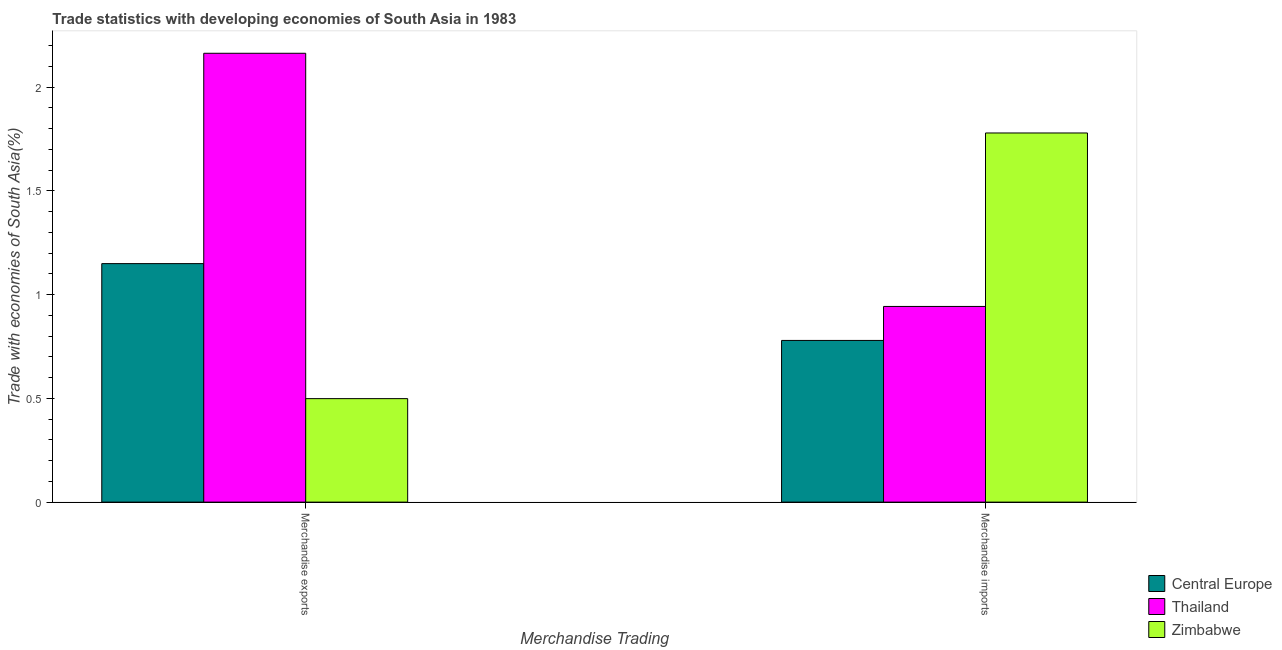Are the number of bars per tick equal to the number of legend labels?
Ensure brevity in your answer.  Yes. Are the number of bars on each tick of the X-axis equal?
Make the answer very short. Yes. How many bars are there on the 1st tick from the left?
Your answer should be very brief. 3. How many bars are there on the 1st tick from the right?
Ensure brevity in your answer.  3. What is the label of the 2nd group of bars from the left?
Ensure brevity in your answer.  Merchandise imports. What is the merchandise exports in Zimbabwe?
Make the answer very short. 0.5. Across all countries, what is the maximum merchandise imports?
Give a very brief answer. 1.78. Across all countries, what is the minimum merchandise imports?
Offer a very short reply. 0.78. In which country was the merchandise exports maximum?
Offer a very short reply. Thailand. In which country was the merchandise exports minimum?
Ensure brevity in your answer.  Zimbabwe. What is the total merchandise exports in the graph?
Your answer should be compact. 3.81. What is the difference between the merchandise imports in Zimbabwe and that in Central Europe?
Your answer should be very brief. 1. What is the difference between the merchandise imports in Zimbabwe and the merchandise exports in Central Europe?
Provide a short and direct response. 0.63. What is the average merchandise imports per country?
Provide a succinct answer. 1.17. What is the difference between the merchandise exports and merchandise imports in Central Europe?
Your answer should be very brief. 0.37. What is the ratio of the merchandise exports in Central Europe to that in Zimbabwe?
Ensure brevity in your answer.  2.3. What does the 3rd bar from the left in Merchandise imports represents?
Offer a terse response. Zimbabwe. What does the 1st bar from the right in Merchandise imports represents?
Offer a very short reply. Zimbabwe. How many bars are there?
Provide a succinct answer. 6. Are all the bars in the graph horizontal?
Make the answer very short. No. How many countries are there in the graph?
Provide a short and direct response. 3. Where does the legend appear in the graph?
Keep it short and to the point. Bottom right. How many legend labels are there?
Offer a very short reply. 3. How are the legend labels stacked?
Provide a succinct answer. Vertical. What is the title of the graph?
Provide a short and direct response. Trade statistics with developing economies of South Asia in 1983. What is the label or title of the X-axis?
Offer a very short reply. Merchandise Trading. What is the label or title of the Y-axis?
Make the answer very short. Trade with economies of South Asia(%). What is the Trade with economies of South Asia(%) in Central Europe in Merchandise exports?
Ensure brevity in your answer.  1.15. What is the Trade with economies of South Asia(%) in Thailand in Merchandise exports?
Give a very brief answer. 2.16. What is the Trade with economies of South Asia(%) of Zimbabwe in Merchandise exports?
Keep it short and to the point. 0.5. What is the Trade with economies of South Asia(%) of Central Europe in Merchandise imports?
Make the answer very short. 0.78. What is the Trade with economies of South Asia(%) in Thailand in Merchandise imports?
Your response must be concise. 0.94. What is the Trade with economies of South Asia(%) of Zimbabwe in Merchandise imports?
Your answer should be very brief. 1.78. Across all Merchandise Trading, what is the maximum Trade with economies of South Asia(%) in Central Europe?
Ensure brevity in your answer.  1.15. Across all Merchandise Trading, what is the maximum Trade with economies of South Asia(%) in Thailand?
Ensure brevity in your answer.  2.16. Across all Merchandise Trading, what is the maximum Trade with economies of South Asia(%) of Zimbabwe?
Your answer should be very brief. 1.78. Across all Merchandise Trading, what is the minimum Trade with economies of South Asia(%) of Central Europe?
Your response must be concise. 0.78. Across all Merchandise Trading, what is the minimum Trade with economies of South Asia(%) in Thailand?
Provide a short and direct response. 0.94. Across all Merchandise Trading, what is the minimum Trade with economies of South Asia(%) of Zimbabwe?
Your response must be concise. 0.5. What is the total Trade with economies of South Asia(%) in Central Europe in the graph?
Offer a terse response. 1.93. What is the total Trade with economies of South Asia(%) of Thailand in the graph?
Ensure brevity in your answer.  3.11. What is the total Trade with economies of South Asia(%) in Zimbabwe in the graph?
Your answer should be very brief. 2.28. What is the difference between the Trade with economies of South Asia(%) of Central Europe in Merchandise exports and that in Merchandise imports?
Keep it short and to the point. 0.37. What is the difference between the Trade with economies of South Asia(%) in Thailand in Merchandise exports and that in Merchandise imports?
Make the answer very short. 1.22. What is the difference between the Trade with economies of South Asia(%) in Zimbabwe in Merchandise exports and that in Merchandise imports?
Make the answer very short. -1.28. What is the difference between the Trade with economies of South Asia(%) in Central Europe in Merchandise exports and the Trade with economies of South Asia(%) in Thailand in Merchandise imports?
Your answer should be very brief. 0.21. What is the difference between the Trade with economies of South Asia(%) in Central Europe in Merchandise exports and the Trade with economies of South Asia(%) in Zimbabwe in Merchandise imports?
Your answer should be compact. -0.63. What is the difference between the Trade with economies of South Asia(%) of Thailand in Merchandise exports and the Trade with economies of South Asia(%) of Zimbabwe in Merchandise imports?
Provide a succinct answer. 0.38. What is the average Trade with economies of South Asia(%) in Central Europe per Merchandise Trading?
Your answer should be very brief. 0.96. What is the average Trade with economies of South Asia(%) of Thailand per Merchandise Trading?
Give a very brief answer. 1.55. What is the average Trade with economies of South Asia(%) of Zimbabwe per Merchandise Trading?
Ensure brevity in your answer.  1.14. What is the difference between the Trade with economies of South Asia(%) of Central Europe and Trade with economies of South Asia(%) of Thailand in Merchandise exports?
Ensure brevity in your answer.  -1.01. What is the difference between the Trade with economies of South Asia(%) of Central Europe and Trade with economies of South Asia(%) of Zimbabwe in Merchandise exports?
Offer a very short reply. 0.65. What is the difference between the Trade with economies of South Asia(%) in Thailand and Trade with economies of South Asia(%) in Zimbabwe in Merchandise exports?
Offer a very short reply. 1.66. What is the difference between the Trade with economies of South Asia(%) of Central Europe and Trade with economies of South Asia(%) of Thailand in Merchandise imports?
Your answer should be compact. -0.16. What is the difference between the Trade with economies of South Asia(%) in Central Europe and Trade with economies of South Asia(%) in Zimbabwe in Merchandise imports?
Offer a very short reply. -1. What is the difference between the Trade with economies of South Asia(%) in Thailand and Trade with economies of South Asia(%) in Zimbabwe in Merchandise imports?
Give a very brief answer. -0.84. What is the ratio of the Trade with economies of South Asia(%) in Central Europe in Merchandise exports to that in Merchandise imports?
Make the answer very short. 1.48. What is the ratio of the Trade with economies of South Asia(%) of Thailand in Merchandise exports to that in Merchandise imports?
Your answer should be very brief. 2.29. What is the ratio of the Trade with economies of South Asia(%) of Zimbabwe in Merchandise exports to that in Merchandise imports?
Your answer should be very brief. 0.28. What is the difference between the highest and the second highest Trade with economies of South Asia(%) of Central Europe?
Your answer should be compact. 0.37. What is the difference between the highest and the second highest Trade with economies of South Asia(%) in Thailand?
Provide a short and direct response. 1.22. What is the difference between the highest and the second highest Trade with economies of South Asia(%) of Zimbabwe?
Offer a terse response. 1.28. What is the difference between the highest and the lowest Trade with economies of South Asia(%) of Central Europe?
Offer a very short reply. 0.37. What is the difference between the highest and the lowest Trade with economies of South Asia(%) in Thailand?
Offer a terse response. 1.22. What is the difference between the highest and the lowest Trade with economies of South Asia(%) of Zimbabwe?
Offer a very short reply. 1.28. 